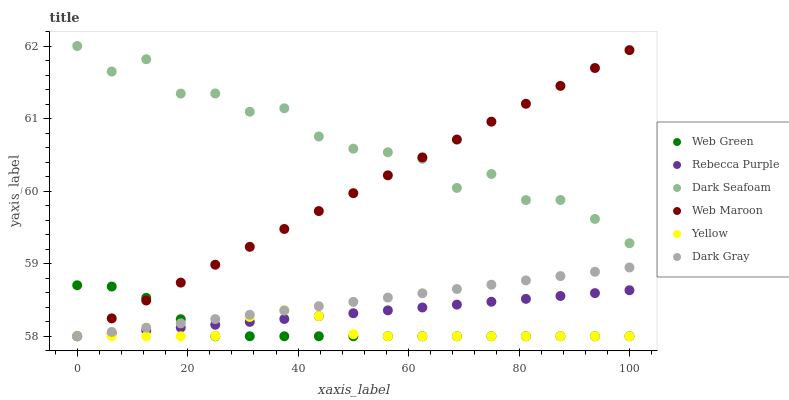Does Yellow have the minimum area under the curve?
Answer yes or no. Yes. Does Dark Seafoam have the maximum area under the curve?
Answer yes or no. Yes. Does Web Maroon have the minimum area under the curve?
Answer yes or no. No. Does Web Maroon have the maximum area under the curve?
Answer yes or no. No. Is Web Maroon the smoothest?
Answer yes or no. Yes. Is Dark Seafoam the roughest?
Answer yes or no. Yes. Is Yellow the smoothest?
Answer yes or no. No. Is Yellow the roughest?
Answer yes or no. No. Does Web Green have the lowest value?
Answer yes or no. Yes. Does Dark Seafoam have the lowest value?
Answer yes or no. No. Does Dark Seafoam have the highest value?
Answer yes or no. Yes. Does Web Maroon have the highest value?
Answer yes or no. No. Is Web Green less than Dark Seafoam?
Answer yes or no. Yes. Is Dark Seafoam greater than Dark Gray?
Answer yes or no. Yes. Does Dark Gray intersect Yellow?
Answer yes or no. Yes. Is Dark Gray less than Yellow?
Answer yes or no. No. Is Dark Gray greater than Yellow?
Answer yes or no. No. Does Web Green intersect Dark Seafoam?
Answer yes or no. No. 